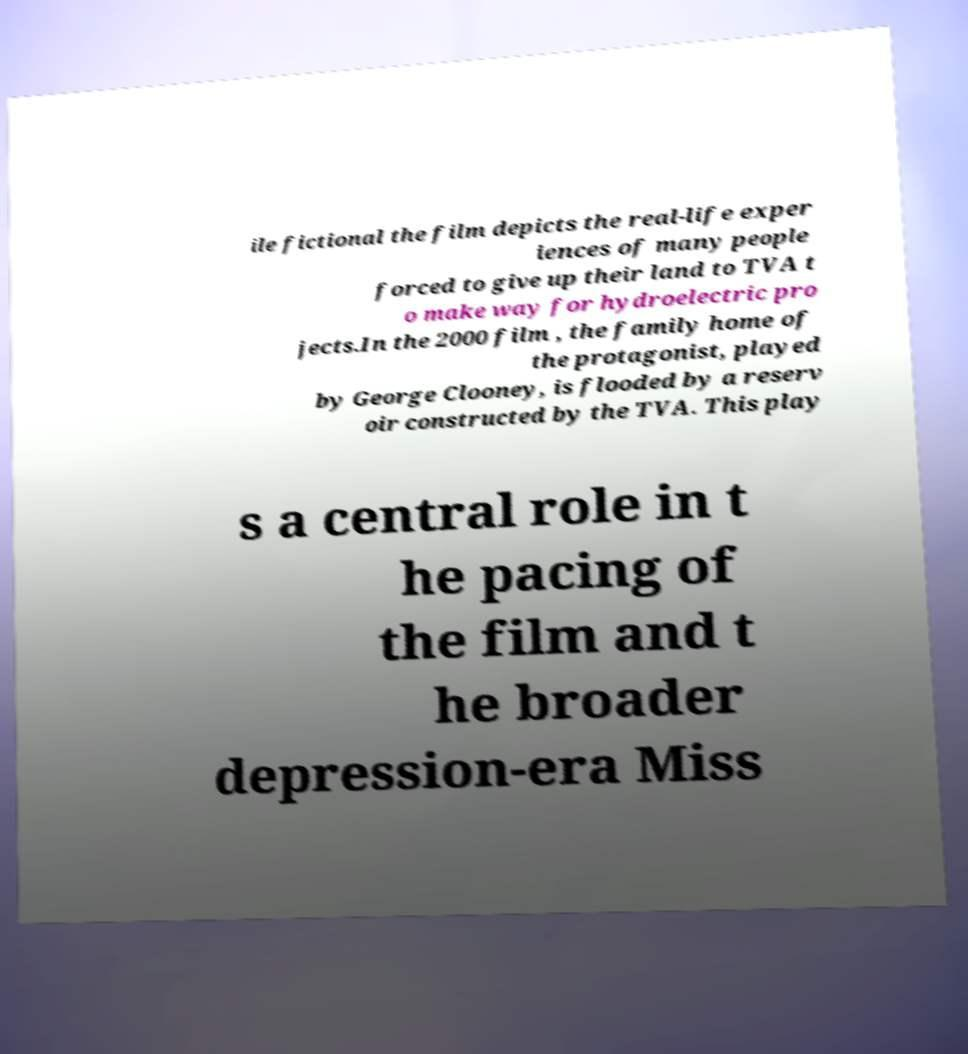Can you read and provide the text displayed in the image?This photo seems to have some interesting text. Can you extract and type it out for me? ile fictional the film depicts the real-life exper iences of many people forced to give up their land to TVA t o make way for hydroelectric pro jects.In the 2000 film , the family home of the protagonist, played by George Clooney, is flooded by a reserv oir constructed by the TVA. This play s a central role in t he pacing of the film and t he broader depression-era Miss 